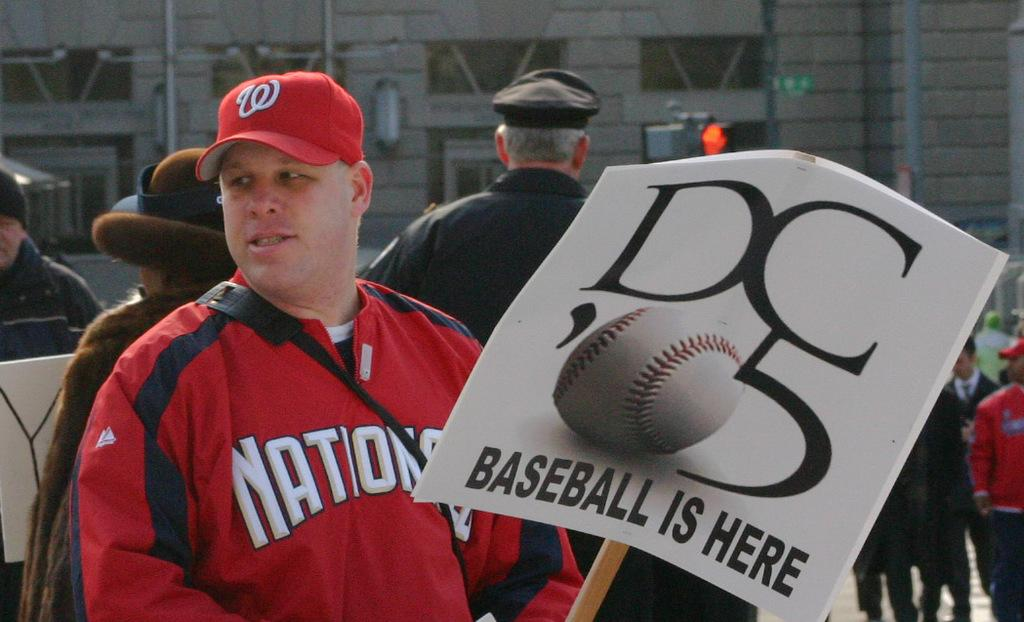<image>
Give a short and clear explanation of the subsequent image. A man wearing a red cap and jacket holds a placard which tells us DC 05 baseball is here. 